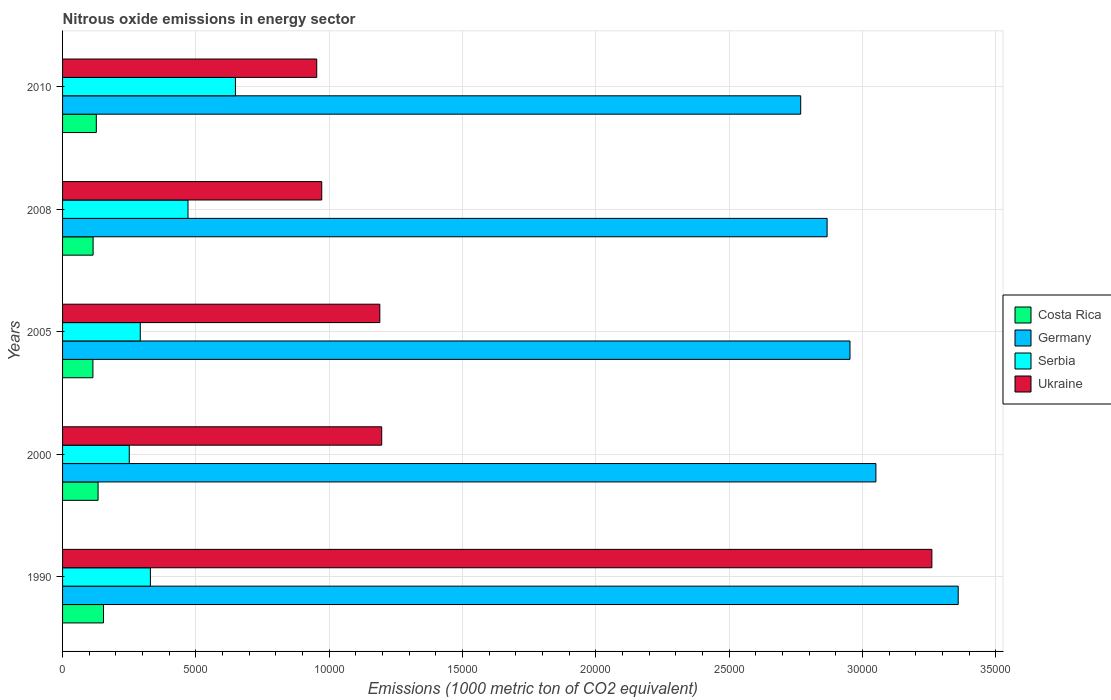How many groups of bars are there?
Keep it short and to the point. 5. Are the number of bars on each tick of the Y-axis equal?
Give a very brief answer. Yes. How many bars are there on the 1st tick from the top?
Your answer should be compact. 4. How many bars are there on the 1st tick from the bottom?
Your answer should be compact. 4. What is the amount of nitrous oxide emitted in Serbia in 2008?
Ensure brevity in your answer.  4703.6. Across all years, what is the maximum amount of nitrous oxide emitted in Ukraine?
Give a very brief answer. 3.26e+04. Across all years, what is the minimum amount of nitrous oxide emitted in Ukraine?
Keep it short and to the point. 9531.4. In which year was the amount of nitrous oxide emitted in Costa Rica maximum?
Give a very brief answer. 1990. What is the total amount of nitrous oxide emitted in Germany in the graph?
Your answer should be compact. 1.50e+05. What is the difference between the amount of nitrous oxide emitted in Ukraine in 2000 and that in 2008?
Your answer should be very brief. 2248.8. What is the difference between the amount of nitrous oxide emitted in Serbia in 1990 and the amount of nitrous oxide emitted in Costa Rica in 2000?
Offer a terse response. 1962. What is the average amount of nitrous oxide emitted in Serbia per year?
Your response must be concise. 3979.06. In the year 2000, what is the difference between the amount of nitrous oxide emitted in Ukraine and amount of nitrous oxide emitted in Costa Rica?
Provide a succinct answer. 1.06e+04. In how many years, is the amount of nitrous oxide emitted in Costa Rica greater than 28000 1000 metric ton?
Make the answer very short. 0. What is the ratio of the amount of nitrous oxide emitted in Serbia in 1990 to that in 2008?
Keep it short and to the point. 0.7. Is the difference between the amount of nitrous oxide emitted in Ukraine in 2000 and 2008 greater than the difference between the amount of nitrous oxide emitted in Costa Rica in 2000 and 2008?
Give a very brief answer. Yes. What is the difference between the highest and the second highest amount of nitrous oxide emitted in Serbia?
Provide a short and direct response. 1779.1. What is the difference between the highest and the lowest amount of nitrous oxide emitted in Serbia?
Ensure brevity in your answer.  3981.3. Is it the case that in every year, the sum of the amount of nitrous oxide emitted in Serbia and amount of nitrous oxide emitted in Ukraine is greater than the sum of amount of nitrous oxide emitted in Germany and amount of nitrous oxide emitted in Costa Rica?
Offer a terse response. Yes. What does the 2nd bar from the top in 2010 represents?
Provide a succinct answer. Serbia. How many bars are there?
Offer a terse response. 20. What is the difference between two consecutive major ticks on the X-axis?
Your response must be concise. 5000. Are the values on the major ticks of X-axis written in scientific E-notation?
Provide a short and direct response. No. Does the graph contain any zero values?
Your answer should be very brief. No. Does the graph contain grids?
Keep it short and to the point. Yes. How are the legend labels stacked?
Your response must be concise. Vertical. What is the title of the graph?
Your answer should be compact. Nitrous oxide emissions in energy sector. What is the label or title of the X-axis?
Your answer should be very brief. Emissions (1000 metric ton of CO2 equivalent). What is the label or title of the Y-axis?
Your answer should be very brief. Years. What is the Emissions (1000 metric ton of CO2 equivalent) in Costa Rica in 1990?
Your response must be concise. 1535. What is the Emissions (1000 metric ton of CO2 equivalent) of Germany in 1990?
Provide a short and direct response. 3.36e+04. What is the Emissions (1000 metric ton of CO2 equivalent) of Serbia in 1990?
Make the answer very short. 3293.8. What is the Emissions (1000 metric ton of CO2 equivalent) in Ukraine in 1990?
Keep it short and to the point. 3.26e+04. What is the Emissions (1000 metric ton of CO2 equivalent) of Costa Rica in 2000?
Keep it short and to the point. 1331.8. What is the Emissions (1000 metric ton of CO2 equivalent) of Germany in 2000?
Your answer should be very brief. 3.05e+04. What is the Emissions (1000 metric ton of CO2 equivalent) of Serbia in 2000?
Keep it short and to the point. 2501.4. What is the Emissions (1000 metric ton of CO2 equivalent) of Ukraine in 2000?
Ensure brevity in your answer.  1.20e+04. What is the Emissions (1000 metric ton of CO2 equivalent) of Costa Rica in 2005?
Your response must be concise. 1138.2. What is the Emissions (1000 metric ton of CO2 equivalent) of Germany in 2005?
Your answer should be compact. 2.95e+04. What is the Emissions (1000 metric ton of CO2 equivalent) in Serbia in 2005?
Your answer should be very brief. 2913.8. What is the Emissions (1000 metric ton of CO2 equivalent) of Ukraine in 2005?
Make the answer very short. 1.19e+04. What is the Emissions (1000 metric ton of CO2 equivalent) in Costa Rica in 2008?
Offer a very short reply. 1145.2. What is the Emissions (1000 metric ton of CO2 equivalent) of Germany in 2008?
Give a very brief answer. 2.87e+04. What is the Emissions (1000 metric ton of CO2 equivalent) of Serbia in 2008?
Offer a very short reply. 4703.6. What is the Emissions (1000 metric ton of CO2 equivalent) in Ukraine in 2008?
Your response must be concise. 9719.1. What is the Emissions (1000 metric ton of CO2 equivalent) in Costa Rica in 2010?
Offer a terse response. 1265.7. What is the Emissions (1000 metric ton of CO2 equivalent) of Germany in 2010?
Your answer should be compact. 2.77e+04. What is the Emissions (1000 metric ton of CO2 equivalent) of Serbia in 2010?
Provide a short and direct response. 6482.7. What is the Emissions (1000 metric ton of CO2 equivalent) in Ukraine in 2010?
Offer a very short reply. 9531.4. Across all years, what is the maximum Emissions (1000 metric ton of CO2 equivalent) in Costa Rica?
Provide a succinct answer. 1535. Across all years, what is the maximum Emissions (1000 metric ton of CO2 equivalent) of Germany?
Make the answer very short. 3.36e+04. Across all years, what is the maximum Emissions (1000 metric ton of CO2 equivalent) in Serbia?
Make the answer very short. 6482.7. Across all years, what is the maximum Emissions (1000 metric ton of CO2 equivalent) in Ukraine?
Provide a short and direct response. 3.26e+04. Across all years, what is the minimum Emissions (1000 metric ton of CO2 equivalent) of Costa Rica?
Keep it short and to the point. 1138.2. Across all years, what is the minimum Emissions (1000 metric ton of CO2 equivalent) of Germany?
Ensure brevity in your answer.  2.77e+04. Across all years, what is the minimum Emissions (1000 metric ton of CO2 equivalent) of Serbia?
Ensure brevity in your answer.  2501.4. Across all years, what is the minimum Emissions (1000 metric ton of CO2 equivalent) of Ukraine?
Your answer should be compact. 9531.4. What is the total Emissions (1000 metric ton of CO2 equivalent) of Costa Rica in the graph?
Provide a succinct answer. 6415.9. What is the total Emissions (1000 metric ton of CO2 equivalent) of Germany in the graph?
Provide a short and direct response. 1.50e+05. What is the total Emissions (1000 metric ton of CO2 equivalent) of Serbia in the graph?
Your answer should be compact. 1.99e+04. What is the total Emissions (1000 metric ton of CO2 equivalent) in Ukraine in the graph?
Your response must be concise. 7.57e+04. What is the difference between the Emissions (1000 metric ton of CO2 equivalent) in Costa Rica in 1990 and that in 2000?
Make the answer very short. 203.2. What is the difference between the Emissions (1000 metric ton of CO2 equivalent) in Germany in 1990 and that in 2000?
Your response must be concise. 3086.2. What is the difference between the Emissions (1000 metric ton of CO2 equivalent) in Serbia in 1990 and that in 2000?
Provide a succinct answer. 792.4. What is the difference between the Emissions (1000 metric ton of CO2 equivalent) of Ukraine in 1990 and that in 2000?
Offer a terse response. 2.06e+04. What is the difference between the Emissions (1000 metric ton of CO2 equivalent) of Costa Rica in 1990 and that in 2005?
Your answer should be very brief. 396.8. What is the difference between the Emissions (1000 metric ton of CO2 equivalent) in Germany in 1990 and that in 2005?
Provide a succinct answer. 4058.7. What is the difference between the Emissions (1000 metric ton of CO2 equivalent) in Serbia in 1990 and that in 2005?
Keep it short and to the point. 380. What is the difference between the Emissions (1000 metric ton of CO2 equivalent) of Ukraine in 1990 and that in 2005?
Your answer should be compact. 2.07e+04. What is the difference between the Emissions (1000 metric ton of CO2 equivalent) in Costa Rica in 1990 and that in 2008?
Ensure brevity in your answer.  389.8. What is the difference between the Emissions (1000 metric ton of CO2 equivalent) of Germany in 1990 and that in 2008?
Give a very brief answer. 4916.5. What is the difference between the Emissions (1000 metric ton of CO2 equivalent) of Serbia in 1990 and that in 2008?
Offer a very short reply. -1409.8. What is the difference between the Emissions (1000 metric ton of CO2 equivalent) in Ukraine in 1990 and that in 2008?
Provide a succinct answer. 2.29e+04. What is the difference between the Emissions (1000 metric ton of CO2 equivalent) in Costa Rica in 1990 and that in 2010?
Provide a succinct answer. 269.3. What is the difference between the Emissions (1000 metric ton of CO2 equivalent) in Germany in 1990 and that in 2010?
Your answer should be very brief. 5906.4. What is the difference between the Emissions (1000 metric ton of CO2 equivalent) of Serbia in 1990 and that in 2010?
Provide a short and direct response. -3188.9. What is the difference between the Emissions (1000 metric ton of CO2 equivalent) of Ukraine in 1990 and that in 2010?
Ensure brevity in your answer.  2.31e+04. What is the difference between the Emissions (1000 metric ton of CO2 equivalent) of Costa Rica in 2000 and that in 2005?
Keep it short and to the point. 193.6. What is the difference between the Emissions (1000 metric ton of CO2 equivalent) in Germany in 2000 and that in 2005?
Offer a very short reply. 972.5. What is the difference between the Emissions (1000 metric ton of CO2 equivalent) of Serbia in 2000 and that in 2005?
Keep it short and to the point. -412.4. What is the difference between the Emissions (1000 metric ton of CO2 equivalent) in Ukraine in 2000 and that in 2005?
Your answer should be compact. 70.4. What is the difference between the Emissions (1000 metric ton of CO2 equivalent) in Costa Rica in 2000 and that in 2008?
Keep it short and to the point. 186.6. What is the difference between the Emissions (1000 metric ton of CO2 equivalent) in Germany in 2000 and that in 2008?
Make the answer very short. 1830.3. What is the difference between the Emissions (1000 metric ton of CO2 equivalent) of Serbia in 2000 and that in 2008?
Make the answer very short. -2202.2. What is the difference between the Emissions (1000 metric ton of CO2 equivalent) in Ukraine in 2000 and that in 2008?
Provide a succinct answer. 2248.8. What is the difference between the Emissions (1000 metric ton of CO2 equivalent) of Costa Rica in 2000 and that in 2010?
Your response must be concise. 66.1. What is the difference between the Emissions (1000 metric ton of CO2 equivalent) of Germany in 2000 and that in 2010?
Offer a terse response. 2820.2. What is the difference between the Emissions (1000 metric ton of CO2 equivalent) of Serbia in 2000 and that in 2010?
Offer a terse response. -3981.3. What is the difference between the Emissions (1000 metric ton of CO2 equivalent) of Ukraine in 2000 and that in 2010?
Provide a short and direct response. 2436.5. What is the difference between the Emissions (1000 metric ton of CO2 equivalent) in Costa Rica in 2005 and that in 2008?
Offer a terse response. -7. What is the difference between the Emissions (1000 metric ton of CO2 equivalent) of Germany in 2005 and that in 2008?
Keep it short and to the point. 857.8. What is the difference between the Emissions (1000 metric ton of CO2 equivalent) in Serbia in 2005 and that in 2008?
Your answer should be very brief. -1789.8. What is the difference between the Emissions (1000 metric ton of CO2 equivalent) of Ukraine in 2005 and that in 2008?
Your answer should be very brief. 2178.4. What is the difference between the Emissions (1000 metric ton of CO2 equivalent) in Costa Rica in 2005 and that in 2010?
Give a very brief answer. -127.5. What is the difference between the Emissions (1000 metric ton of CO2 equivalent) in Germany in 2005 and that in 2010?
Keep it short and to the point. 1847.7. What is the difference between the Emissions (1000 metric ton of CO2 equivalent) in Serbia in 2005 and that in 2010?
Your answer should be very brief. -3568.9. What is the difference between the Emissions (1000 metric ton of CO2 equivalent) of Ukraine in 2005 and that in 2010?
Make the answer very short. 2366.1. What is the difference between the Emissions (1000 metric ton of CO2 equivalent) in Costa Rica in 2008 and that in 2010?
Your answer should be very brief. -120.5. What is the difference between the Emissions (1000 metric ton of CO2 equivalent) in Germany in 2008 and that in 2010?
Offer a very short reply. 989.9. What is the difference between the Emissions (1000 metric ton of CO2 equivalent) of Serbia in 2008 and that in 2010?
Give a very brief answer. -1779.1. What is the difference between the Emissions (1000 metric ton of CO2 equivalent) in Ukraine in 2008 and that in 2010?
Your answer should be compact. 187.7. What is the difference between the Emissions (1000 metric ton of CO2 equivalent) of Costa Rica in 1990 and the Emissions (1000 metric ton of CO2 equivalent) of Germany in 2000?
Give a very brief answer. -2.90e+04. What is the difference between the Emissions (1000 metric ton of CO2 equivalent) in Costa Rica in 1990 and the Emissions (1000 metric ton of CO2 equivalent) in Serbia in 2000?
Your answer should be compact. -966.4. What is the difference between the Emissions (1000 metric ton of CO2 equivalent) in Costa Rica in 1990 and the Emissions (1000 metric ton of CO2 equivalent) in Ukraine in 2000?
Offer a terse response. -1.04e+04. What is the difference between the Emissions (1000 metric ton of CO2 equivalent) of Germany in 1990 and the Emissions (1000 metric ton of CO2 equivalent) of Serbia in 2000?
Give a very brief answer. 3.11e+04. What is the difference between the Emissions (1000 metric ton of CO2 equivalent) in Germany in 1990 and the Emissions (1000 metric ton of CO2 equivalent) in Ukraine in 2000?
Your answer should be compact. 2.16e+04. What is the difference between the Emissions (1000 metric ton of CO2 equivalent) in Serbia in 1990 and the Emissions (1000 metric ton of CO2 equivalent) in Ukraine in 2000?
Offer a terse response. -8674.1. What is the difference between the Emissions (1000 metric ton of CO2 equivalent) in Costa Rica in 1990 and the Emissions (1000 metric ton of CO2 equivalent) in Germany in 2005?
Give a very brief answer. -2.80e+04. What is the difference between the Emissions (1000 metric ton of CO2 equivalent) in Costa Rica in 1990 and the Emissions (1000 metric ton of CO2 equivalent) in Serbia in 2005?
Give a very brief answer. -1378.8. What is the difference between the Emissions (1000 metric ton of CO2 equivalent) in Costa Rica in 1990 and the Emissions (1000 metric ton of CO2 equivalent) in Ukraine in 2005?
Keep it short and to the point. -1.04e+04. What is the difference between the Emissions (1000 metric ton of CO2 equivalent) in Germany in 1990 and the Emissions (1000 metric ton of CO2 equivalent) in Serbia in 2005?
Offer a terse response. 3.07e+04. What is the difference between the Emissions (1000 metric ton of CO2 equivalent) of Germany in 1990 and the Emissions (1000 metric ton of CO2 equivalent) of Ukraine in 2005?
Make the answer very short. 2.17e+04. What is the difference between the Emissions (1000 metric ton of CO2 equivalent) in Serbia in 1990 and the Emissions (1000 metric ton of CO2 equivalent) in Ukraine in 2005?
Keep it short and to the point. -8603.7. What is the difference between the Emissions (1000 metric ton of CO2 equivalent) in Costa Rica in 1990 and the Emissions (1000 metric ton of CO2 equivalent) in Germany in 2008?
Ensure brevity in your answer.  -2.71e+04. What is the difference between the Emissions (1000 metric ton of CO2 equivalent) in Costa Rica in 1990 and the Emissions (1000 metric ton of CO2 equivalent) in Serbia in 2008?
Your response must be concise. -3168.6. What is the difference between the Emissions (1000 metric ton of CO2 equivalent) in Costa Rica in 1990 and the Emissions (1000 metric ton of CO2 equivalent) in Ukraine in 2008?
Your response must be concise. -8184.1. What is the difference between the Emissions (1000 metric ton of CO2 equivalent) in Germany in 1990 and the Emissions (1000 metric ton of CO2 equivalent) in Serbia in 2008?
Keep it short and to the point. 2.89e+04. What is the difference between the Emissions (1000 metric ton of CO2 equivalent) of Germany in 1990 and the Emissions (1000 metric ton of CO2 equivalent) of Ukraine in 2008?
Ensure brevity in your answer.  2.39e+04. What is the difference between the Emissions (1000 metric ton of CO2 equivalent) in Serbia in 1990 and the Emissions (1000 metric ton of CO2 equivalent) in Ukraine in 2008?
Provide a succinct answer. -6425.3. What is the difference between the Emissions (1000 metric ton of CO2 equivalent) in Costa Rica in 1990 and the Emissions (1000 metric ton of CO2 equivalent) in Germany in 2010?
Give a very brief answer. -2.61e+04. What is the difference between the Emissions (1000 metric ton of CO2 equivalent) of Costa Rica in 1990 and the Emissions (1000 metric ton of CO2 equivalent) of Serbia in 2010?
Provide a succinct answer. -4947.7. What is the difference between the Emissions (1000 metric ton of CO2 equivalent) in Costa Rica in 1990 and the Emissions (1000 metric ton of CO2 equivalent) in Ukraine in 2010?
Give a very brief answer. -7996.4. What is the difference between the Emissions (1000 metric ton of CO2 equivalent) of Germany in 1990 and the Emissions (1000 metric ton of CO2 equivalent) of Serbia in 2010?
Provide a short and direct response. 2.71e+04. What is the difference between the Emissions (1000 metric ton of CO2 equivalent) in Germany in 1990 and the Emissions (1000 metric ton of CO2 equivalent) in Ukraine in 2010?
Keep it short and to the point. 2.41e+04. What is the difference between the Emissions (1000 metric ton of CO2 equivalent) of Serbia in 1990 and the Emissions (1000 metric ton of CO2 equivalent) of Ukraine in 2010?
Your answer should be very brief. -6237.6. What is the difference between the Emissions (1000 metric ton of CO2 equivalent) in Costa Rica in 2000 and the Emissions (1000 metric ton of CO2 equivalent) in Germany in 2005?
Your answer should be very brief. -2.82e+04. What is the difference between the Emissions (1000 metric ton of CO2 equivalent) of Costa Rica in 2000 and the Emissions (1000 metric ton of CO2 equivalent) of Serbia in 2005?
Provide a succinct answer. -1582. What is the difference between the Emissions (1000 metric ton of CO2 equivalent) in Costa Rica in 2000 and the Emissions (1000 metric ton of CO2 equivalent) in Ukraine in 2005?
Keep it short and to the point. -1.06e+04. What is the difference between the Emissions (1000 metric ton of CO2 equivalent) of Germany in 2000 and the Emissions (1000 metric ton of CO2 equivalent) of Serbia in 2005?
Provide a short and direct response. 2.76e+04. What is the difference between the Emissions (1000 metric ton of CO2 equivalent) of Germany in 2000 and the Emissions (1000 metric ton of CO2 equivalent) of Ukraine in 2005?
Keep it short and to the point. 1.86e+04. What is the difference between the Emissions (1000 metric ton of CO2 equivalent) of Serbia in 2000 and the Emissions (1000 metric ton of CO2 equivalent) of Ukraine in 2005?
Keep it short and to the point. -9396.1. What is the difference between the Emissions (1000 metric ton of CO2 equivalent) of Costa Rica in 2000 and the Emissions (1000 metric ton of CO2 equivalent) of Germany in 2008?
Keep it short and to the point. -2.73e+04. What is the difference between the Emissions (1000 metric ton of CO2 equivalent) in Costa Rica in 2000 and the Emissions (1000 metric ton of CO2 equivalent) in Serbia in 2008?
Ensure brevity in your answer.  -3371.8. What is the difference between the Emissions (1000 metric ton of CO2 equivalent) in Costa Rica in 2000 and the Emissions (1000 metric ton of CO2 equivalent) in Ukraine in 2008?
Your answer should be very brief. -8387.3. What is the difference between the Emissions (1000 metric ton of CO2 equivalent) of Germany in 2000 and the Emissions (1000 metric ton of CO2 equivalent) of Serbia in 2008?
Your answer should be very brief. 2.58e+04. What is the difference between the Emissions (1000 metric ton of CO2 equivalent) in Germany in 2000 and the Emissions (1000 metric ton of CO2 equivalent) in Ukraine in 2008?
Keep it short and to the point. 2.08e+04. What is the difference between the Emissions (1000 metric ton of CO2 equivalent) of Serbia in 2000 and the Emissions (1000 metric ton of CO2 equivalent) of Ukraine in 2008?
Keep it short and to the point. -7217.7. What is the difference between the Emissions (1000 metric ton of CO2 equivalent) in Costa Rica in 2000 and the Emissions (1000 metric ton of CO2 equivalent) in Germany in 2010?
Your response must be concise. -2.63e+04. What is the difference between the Emissions (1000 metric ton of CO2 equivalent) of Costa Rica in 2000 and the Emissions (1000 metric ton of CO2 equivalent) of Serbia in 2010?
Provide a short and direct response. -5150.9. What is the difference between the Emissions (1000 metric ton of CO2 equivalent) in Costa Rica in 2000 and the Emissions (1000 metric ton of CO2 equivalent) in Ukraine in 2010?
Keep it short and to the point. -8199.6. What is the difference between the Emissions (1000 metric ton of CO2 equivalent) of Germany in 2000 and the Emissions (1000 metric ton of CO2 equivalent) of Serbia in 2010?
Provide a succinct answer. 2.40e+04. What is the difference between the Emissions (1000 metric ton of CO2 equivalent) in Germany in 2000 and the Emissions (1000 metric ton of CO2 equivalent) in Ukraine in 2010?
Your response must be concise. 2.10e+04. What is the difference between the Emissions (1000 metric ton of CO2 equivalent) in Serbia in 2000 and the Emissions (1000 metric ton of CO2 equivalent) in Ukraine in 2010?
Your response must be concise. -7030. What is the difference between the Emissions (1000 metric ton of CO2 equivalent) in Costa Rica in 2005 and the Emissions (1000 metric ton of CO2 equivalent) in Germany in 2008?
Your answer should be very brief. -2.75e+04. What is the difference between the Emissions (1000 metric ton of CO2 equivalent) in Costa Rica in 2005 and the Emissions (1000 metric ton of CO2 equivalent) in Serbia in 2008?
Make the answer very short. -3565.4. What is the difference between the Emissions (1000 metric ton of CO2 equivalent) of Costa Rica in 2005 and the Emissions (1000 metric ton of CO2 equivalent) of Ukraine in 2008?
Your answer should be very brief. -8580.9. What is the difference between the Emissions (1000 metric ton of CO2 equivalent) of Germany in 2005 and the Emissions (1000 metric ton of CO2 equivalent) of Serbia in 2008?
Make the answer very short. 2.48e+04. What is the difference between the Emissions (1000 metric ton of CO2 equivalent) of Germany in 2005 and the Emissions (1000 metric ton of CO2 equivalent) of Ukraine in 2008?
Give a very brief answer. 1.98e+04. What is the difference between the Emissions (1000 metric ton of CO2 equivalent) in Serbia in 2005 and the Emissions (1000 metric ton of CO2 equivalent) in Ukraine in 2008?
Offer a terse response. -6805.3. What is the difference between the Emissions (1000 metric ton of CO2 equivalent) of Costa Rica in 2005 and the Emissions (1000 metric ton of CO2 equivalent) of Germany in 2010?
Your response must be concise. -2.65e+04. What is the difference between the Emissions (1000 metric ton of CO2 equivalent) in Costa Rica in 2005 and the Emissions (1000 metric ton of CO2 equivalent) in Serbia in 2010?
Offer a terse response. -5344.5. What is the difference between the Emissions (1000 metric ton of CO2 equivalent) in Costa Rica in 2005 and the Emissions (1000 metric ton of CO2 equivalent) in Ukraine in 2010?
Your answer should be compact. -8393.2. What is the difference between the Emissions (1000 metric ton of CO2 equivalent) in Germany in 2005 and the Emissions (1000 metric ton of CO2 equivalent) in Serbia in 2010?
Offer a terse response. 2.30e+04. What is the difference between the Emissions (1000 metric ton of CO2 equivalent) of Germany in 2005 and the Emissions (1000 metric ton of CO2 equivalent) of Ukraine in 2010?
Provide a short and direct response. 2.00e+04. What is the difference between the Emissions (1000 metric ton of CO2 equivalent) in Serbia in 2005 and the Emissions (1000 metric ton of CO2 equivalent) in Ukraine in 2010?
Provide a succinct answer. -6617.6. What is the difference between the Emissions (1000 metric ton of CO2 equivalent) of Costa Rica in 2008 and the Emissions (1000 metric ton of CO2 equivalent) of Germany in 2010?
Your response must be concise. -2.65e+04. What is the difference between the Emissions (1000 metric ton of CO2 equivalent) of Costa Rica in 2008 and the Emissions (1000 metric ton of CO2 equivalent) of Serbia in 2010?
Keep it short and to the point. -5337.5. What is the difference between the Emissions (1000 metric ton of CO2 equivalent) in Costa Rica in 2008 and the Emissions (1000 metric ton of CO2 equivalent) in Ukraine in 2010?
Provide a succinct answer. -8386.2. What is the difference between the Emissions (1000 metric ton of CO2 equivalent) of Germany in 2008 and the Emissions (1000 metric ton of CO2 equivalent) of Serbia in 2010?
Make the answer very short. 2.22e+04. What is the difference between the Emissions (1000 metric ton of CO2 equivalent) in Germany in 2008 and the Emissions (1000 metric ton of CO2 equivalent) in Ukraine in 2010?
Provide a succinct answer. 1.91e+04. What is the difference between the Emissions (1000 metric ton of CO2 equivalent) of Serbia in 2008 and the Emissions (1000 metric ton of CO2 equivalent) of Ukraine in 2010?
Provide a short and direct response. -4827.8. What is the average Emissions (1000 metric ton of CO2 equivalent) of Costa Rica per year?
Give a very brief answer. 1283.18. What is the average Emissions (1000 metric ton of CO2 equivalent) of Germany per year?
Your response must be concise. 3.00e+04. What is the average Emissions (1000 metric ton of CO2 equivalent) of Serbia per year?
Make the answer very short. 3979.06. What is the average Emissions (1000 metric ton of CO2 equivalent) in Ukraine per year?
Offer a very short reply. 1.51e+04. In the year 1990, what is the difference between the Emissions (1000 metric ton of CO2 equivalent) of Costa Rica and Emissions (1000 metric ton of CO2 equivalent) of Germany?
Offer a terse response. -3.21e+04. In the year 1990, what is the difference between the Emissions (1000 metric ton of CO2 equivalent) in Costa Rica and Emissions (1000 metric ton of CO2 equivalent) in Serbia?
Give a very brief answer. -1758.8. In the year 1990, what is the difference between the Emissions (1000 metric ton of CO2 equivalent) of Costa Rica and Emissions (1000 metric ton of CO2 equivalent) of Ukraine?
Offer a terse response. -3.11e+04. In the year 1990, what is the difference between the Emissions (1000 metric ton of CO2 equivalent) in Germany and Emissions (1000 metric ton of CO2 equivalent) in Serbia?
Offer a very short reply. 3.03e+04. In the year 1990, what is the difference between the Emissions (1000 metric ton of CO2 equivalent) in Germany and Emissions (1000 metric ton of CO2 equivalent) in Ukraine?
Ensure brevity in your answer.  987. In the year 1990, what is the difference between the Emissions (1000 metric ton of CO2 equivalent) in Serbia and Emissions (1000 metric ton of CO2 equivalent) in Ukraine?
Provide a short and direct response. -2.93e+04. In the year 2000, what is the difference between the Emissions (1000 metric ton of CO2 equivalent) of Costa Rica and Emissions (1000 metric ton of CO2 equivalent) of Germany?
Offer a terse response. -2.92e+04. In the year 2000, what is the difference between the Emissions (1000 metric ton of CO2 equivalent) in Costa Rica and Emissions (1000 metric ton of CO2 equivalent) in Serbia?
Your answer should be very brief. -1169.6. In the year 2000, what is the difference between the Emissions (1000 metric ton of CO2 equivalent) of Costa Rica and Emissions (1000 metric ton of CO2 equivalent) of Ukraine?
Offer a terse response. -1.06e+04. In the year 2000, what is the difference between the Emissions (1000 metric ton of CO2 equivalent) of Germany and Emissions (1000 metric ton of CO2 equivalent) of Serbia?
Offer a terse response. 2.80e+04. In the year 2000, what is the difference between the Emissions (1000 metric ton of CO2 equivalent) in Germany and Emissions (1000 metric ton of CO2 equivalent) in Ukraine?
Keep it short and to the point. 1.85e+04. In the year 2000, what is the difference between the Emissions (1000 metric ton of CO2 equivalent) of Serbia and Emissions (1000 metric ton of CO2 equivalent) of Ukraine?
Make the answer very short. -9466.5. In the year 2005, what is the difference between the Emissions (1000 metric ton of CO2 equivalent) of Costa Rica and Emissions (1000 metric ton of CO2 equivalent) of Germany?
Ensure brevity in your answer.  -2.84e+04. In the year 2005, what is the difference between the Emissions (1000 metric ton of CO2 equivalent) in Costa Rica and Emissions (1000 metric ton of CO2 equivalent) in Serbia?
Give a very brief answer. -1775.6. In the year 2005, what is the difference between the Emissions (1000 metric ton of CO2 equivalent) of Costa Rica and Emissions (1000 metric ton of CO2 equivalent) of Ukraine?
Give a very brief answer. -1.08e+04. In the year 2005, what is the difference between the Emissions (1000 metric ton of CO2 equivalent) of Germany and Emissions (1000 metric ton of CO2 equivalent) of Serbia?
Make the answer very short. 2.66e+04. In the year 2005, what is the difference between the Emissions (1000 metric ton of CO2 equivalent) in Germany and Emissions (1000 metric ton of CO2 equivalent) in Ukraine?
Provide a succinct answer. 1.76e+04. In the year 2005, what is the difference between the Emissions (1000 metric ton of CO2 equivalent) in Serbia and Emissions (1000 metric ton of CO2 equivalent) in Ukraine?
Provide a short and direct response. -8983.7. In the year 2008, what is the difference between the Emissions (1000 metric ton of CO2 equivalent) of Costa Rica and Emissions (1000 metric ton of CO2 equivalent) of Germany?
Give a very brief answer. -2.75e+04. In the year 2008, what is the difference between the Emissions (1000 metric ton of CO2 equivalent) of Costa Rica and Emissions (1000 metric ton of CO2 equivalent) of Serbia?
Offer a very short reply. -3558.4. In the year 2008, what is the difference between the Emissions (1000 metric ton of CO2 equivalent) of Costa Rica and Emissions (1000 metric ton of CO2 equivalent) of Ukraine?
Your response must be concise. -8573.9. In the year 2008, what is the difference between the Emissions (1000 metric ton of CO2 equivalent) in Germany and Emissions (1000 metric ton of CO2 equivalent) in Serbia?
Keep it short and to the point. 2.40e+04. In the year 2008, what is the difference between the Emissions (1000 metric ton of CO2 equivalent) in Germany and Emissions (1000 metric ton of CO2 equivalent) in Ukraine?
Offer a very short reply. 1.90e+04. In the year 2008, what is the difference between the Emissions (1000 metric ton of CO2 equivalent) of Serbia and Emissions (1000 metric ton of CO2 equivalent) of Ukraine?
Give a very brief answer. -5015.5. In the year 2010, what is the difference between the Emissions (1000 metric ton of CO2 equivalent) of Costa Rica and Emissions (1000 metric ton of CO2 equivalent) of Germany?
Your response must be concise. -2.64e+04. In the year 2010, what is the difference between the Emissions (1000 metric ton of CO2 equivalent) in Costa Rica and Emissions (1000 metric ton of CO2 equivalent) in Serbia?
Your response must be concise. -5217. In the year 2010, what is the difference between the Emissions (1000 metric ton of CO2 equivalent) of Costa Rica and Emissions (1000 metric ton of CO2 equivalent) of Ukraine?
Your response must be concise. -8265.7. In the year 2010, what is the difference between the Emissions (1000 metric ton of CO2 equivalent) in Germany and Emissions (1000 metric ton of CO2 equivalent) in Serbia?
Your answer should be very brief. 2.12e+04. In the year 2010, what is the difference between the Emissions (1000 metric ton of CO2 equivalent) in Germany and Emissions (1000 metric ton of CO2 equivalent) in Ukraine?
Give a very brief answer. 1.81e+04. In the year 2010, what is the difference between the Emissions (1000 metric ton of CO2 equivalent) of Serbia and Emissions (1000 metric ton of CO2 equivalent) of Ukraine?
Give a very brief answer. -3048.7. What is the ratio of the Emissions (1000 metric ton of CO2 equivalent) of Costa Rica in 1990 to that in 2000?
Give a very brief answer. 1.15. What is the ratio of the Emissions (1000 metric ton of CO2 equivalent) of Germany in 1990 to that in 2000?
Provide a short and direct response. 1.1. What is the ratio of the Emissions (1000 metric ton of CO2 equivalent) in Serbia in 1990 to that in 2000?
Make the answer very short. 1.32. What is the ratio of the Emissions (1000 metric ton of CO2 equivalent) of Ukraine in 1990 to that in 2000?
Give a very brief answer. 2.72. What is the ratio of the Emissions (1000 metric ton of CO2 equivalent) of Costa Rica in 1990 to that in 2005?
Give a very brief answer. 1.35. What is the ratio of the Emissions (1000 metric ton of CO2 equivalent) in Germany in 1990 to that in 2005?
Offer a terse response. 1.14. What is the ratio of the Emissions (1000 metric ton of CO2 equivalent) in Serbia in 1990 to that in 2005?
Ensure brevity in your answer.  1.13. What is the ratio of the Emissions (1000 metric ton of CO2 equivalent) of Ukraine in 1990 to that in 2005?
Offer a terse response. 2.74. What is the ratio of the Emissions (1000 metric ton of CO2 equivalent) of Costa Rica in 1990 to that in 2008?
Provide a succinct answer. 1.34. What is the ratio of the Emissions (1000 metric ton of CO2 equivalent) of Germany in 1990 to that in 2008?
Give a very brief answer. 1.17. What is the ratio of the Emissions (1000 metric ton of CO2 equivalent) in Serbia in 1990 to that in 2008?
Your answer should be compact. 0.7. What is the ratio of the Emissions (1000 metric ton of CO2 equivalent) of Ukraine in 1990 to that in 2008?
Provide a short and direct response. 3.35. What is the ratio of the Emissions (1000 metric ton of CO2 equivalent) of Costa Rica in 1990 to that in 2010?
Offer a very short reply. 1.21. What is the ratio of the Emissions (1000 metric ton of CO2 equivalent) in Germany in 1990 to that in 2010?
Offer a very short reply. 1.21. What is the ratio of the Emissions (1000 metric ton of CO2 equivalent) in Serbia in 1990 to that in 2010?
Offer a very short reply. 0.51. What is the ratio of the Emissions (1000 metric ton of CO2 equivalent) of Ukraine in 1990 to that in 2010?
Offer a very short reply. 3.42. What is the ratio of the Emissions (1000 metric ton of CO2 equivalent) in Costa Rica in 2000 to that in 2005?
Offer a terse response. 1.17. What is the ratio of the Emissions (1000 metric ton of CO2 equivalent) in Germany in 2000 to that in 2005?
Keep it short and to the point. 1.03. What is the ratio of the Emissions (1000 metric ton of CO2 equivalent) of Serbia in 2000 to that in 2005?
Offer a terse response. 0.86. What is the ratio of the Emissions (1000 metric ton of CO2 equivalent) of Ukraine in 2000 to that in 2005?
Offer a very short reply. 1.01. What is the ratio of the Emissions (1000 metric ton of CO2 equivalent) of Costa Rica in 2000 to that in 2008?
Offer a very short reply. 1.16. What is the ratio of the Emissions (1000 metric ton of CO2 equivalent) of Germany in 2000 to that in 2008?
Offer a very short reply. 1.06. What is the ratio of the Emissions (1000 metric ton of CO2 equivalent) of Serbia in 2000 to that in 2008?
Ensure brevity in your answer.  0.53. What is the ratio of the Emissions (1000 metric ton of CO2 equivalent) in Ukraine in 2000 to that in 2008?
Offer a very short reply. 1.23. What is the ratio of the Emissions (1000 metric ton of CO2 equivalent) of Costa Rica in 2000 to that in 2010?
Offer a very short reply. 1.05. What is the ratio of the Emissions (1000 metric ton of CO2 equivalent) in Germany in 2000 to that in 2010?
Ensure brevity in your answer.  1.1. What is the ratio of the Emissions (1000 metric ton of CO2 equivalent) of Serbia in 2000 to that in 2010?
Keep it short and to the point. 0.39. What is the ratio of the Emissions (1000 metric ton of CO2 equivalent) in Ukraine in 2000 to that in 2010?
Provide a succinct answer. 1.26. What is the ratio of the Emissions (1000 metric ton of CO2 equivalent) of Costa Rica in 2005 to that in 2008?
Your answer should be very brief. 0.99. What is the ratio of the Emissions (1000 metric ton of CO2 equivalent) of Germany in 2005 to that in 2008?
Keep it short and to the point. 1.03. What is the ratio of the Emissions (1000 metric ton of CO2 equivalent) of Serbia in 2005 to that in 2008?
Provide a succinct answer. 0.62. What is the ratio of the Emissions (1000 metric ton of CO2 equivalent) of Ukraine in 2005 to that in 2008?
Your answer should be very brief. 1.22. What is the ratio of the Emissions (1000 metric ton of CO2 equivalent) in Costa Rica in 2005 to that in 2010?
Offer a very short reply. 0.9. What is the ratio of the Emissions (1000 metric ton of CO2 equivalent) of Germany in 2005 to that in 2010?
Make the answer very short. 1.07. What is the ratio of the Emissions (1000 metric ton of CO2 equivalent) of Serbia in 2005 to that in 2010?
Provide a short and direct response. 0.45. What is the ratio of the Emissions (1000 metric ton of CO2 equivalent) in Ukraine in 2005 to that in 2010?
Make the answer very short. 1.25. What is the ratio of the Emissions (1000 metric ton of CO2 equivalent) in Costa Rica in 2008 to that in 2010?
Ensure brevity in your answer.  0.9. What is the ratio of the Emissions (1000 metric ton of CO2 equivalent) of Germany in 2008 to that in 2010?
Ensure brevity in your answer.  1.04. What is the ratio of the Emissions (1000 metric ton of CO2 equivalent) of Serbia in 2008 to that in 2010?
Your response must be concise. 0.73. What is the ratio of the Emissions (1000 metric ton of CO2 equivalent) of Ukraine in 2008 to that in 2010?
Offer a very short reply. 1.02. What is the difference between the highest and the second highest Emissions (1000 metric ton of CO2 equivalent) in Costa Rica?
Your response must be concise. 203.2. What is the difference between the highest and the second highest Emissions (1000 metric ton of CO2 equivalent) of Germany?
Offer a terse response. 3086.2. What is the difference between the highest and the second highest Emissions (1000 metric ton of CO2 equivalent) in Serbia?
Ensure brevity in your answer.  1779.1. What is the difference between the highest and the second highest Emissions (1000 metric ton of CO2 equivalent) of Ukraine?
Offer a terse response. 2.06e+04. What is the difference between the highest and the lowest Emissions (1000 metric ton of CO2 equivalent) in Costa Rica?
Make the answer very short. 396.8. What is the difference between the highest and the lowest Emissions (1000 metric ton of CO2 equivalent) of Germany?
Give a very brief answer. 5906.4. What is the difference between the highest and the lowest Emissions (1000 metric ton of CO2 equivalent) of Serbia?
Your answer should be compact. 3981.3. What is the difference between the highest and the lowest Emissions (1000 metric ton of CO2 equivalent) in Ukraine?
Offer a terse response. 2.31e+04. 